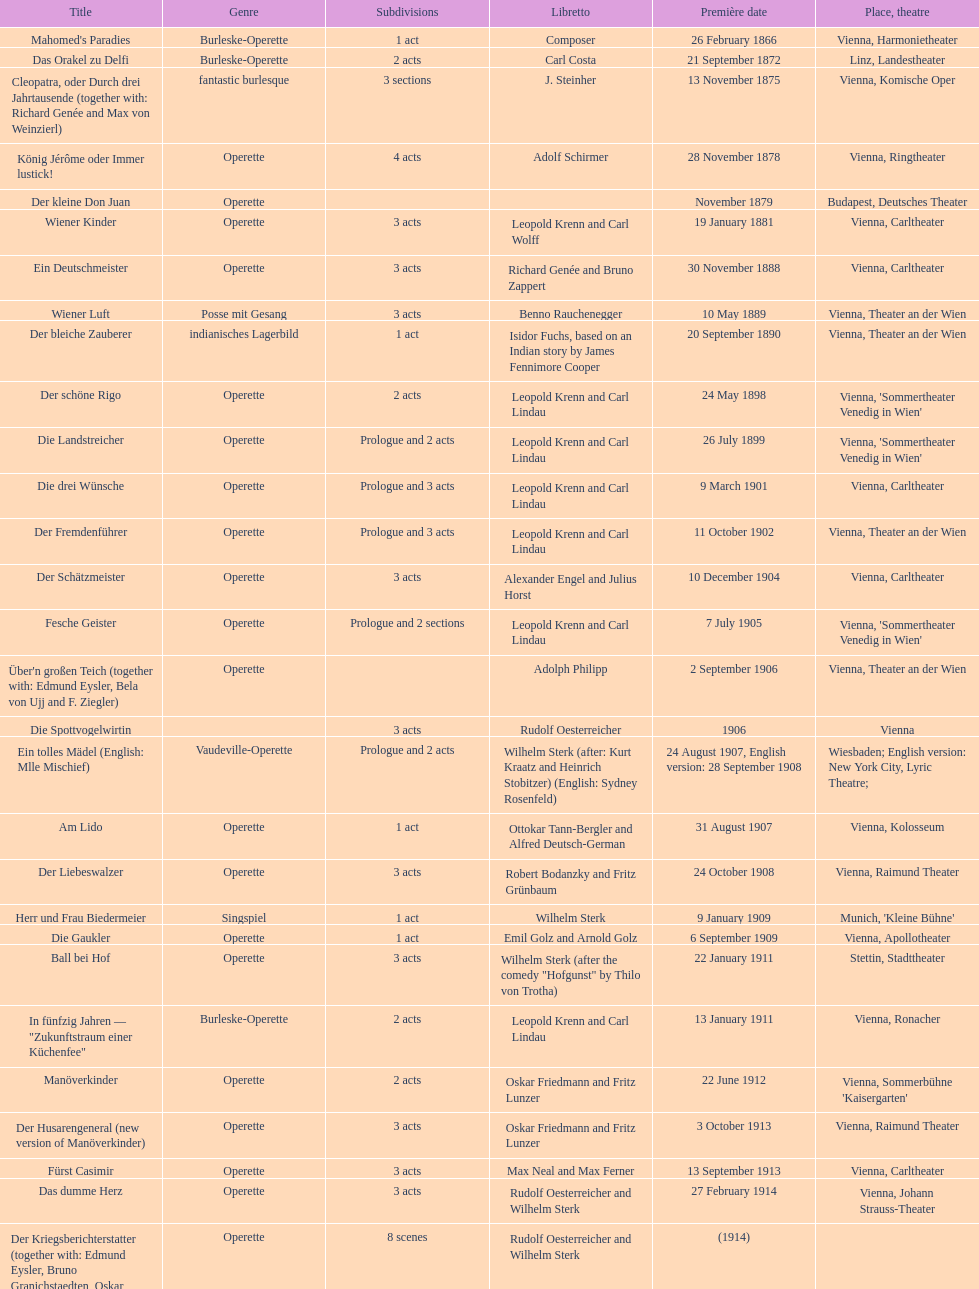How many number of 1 acts were there? 5. 